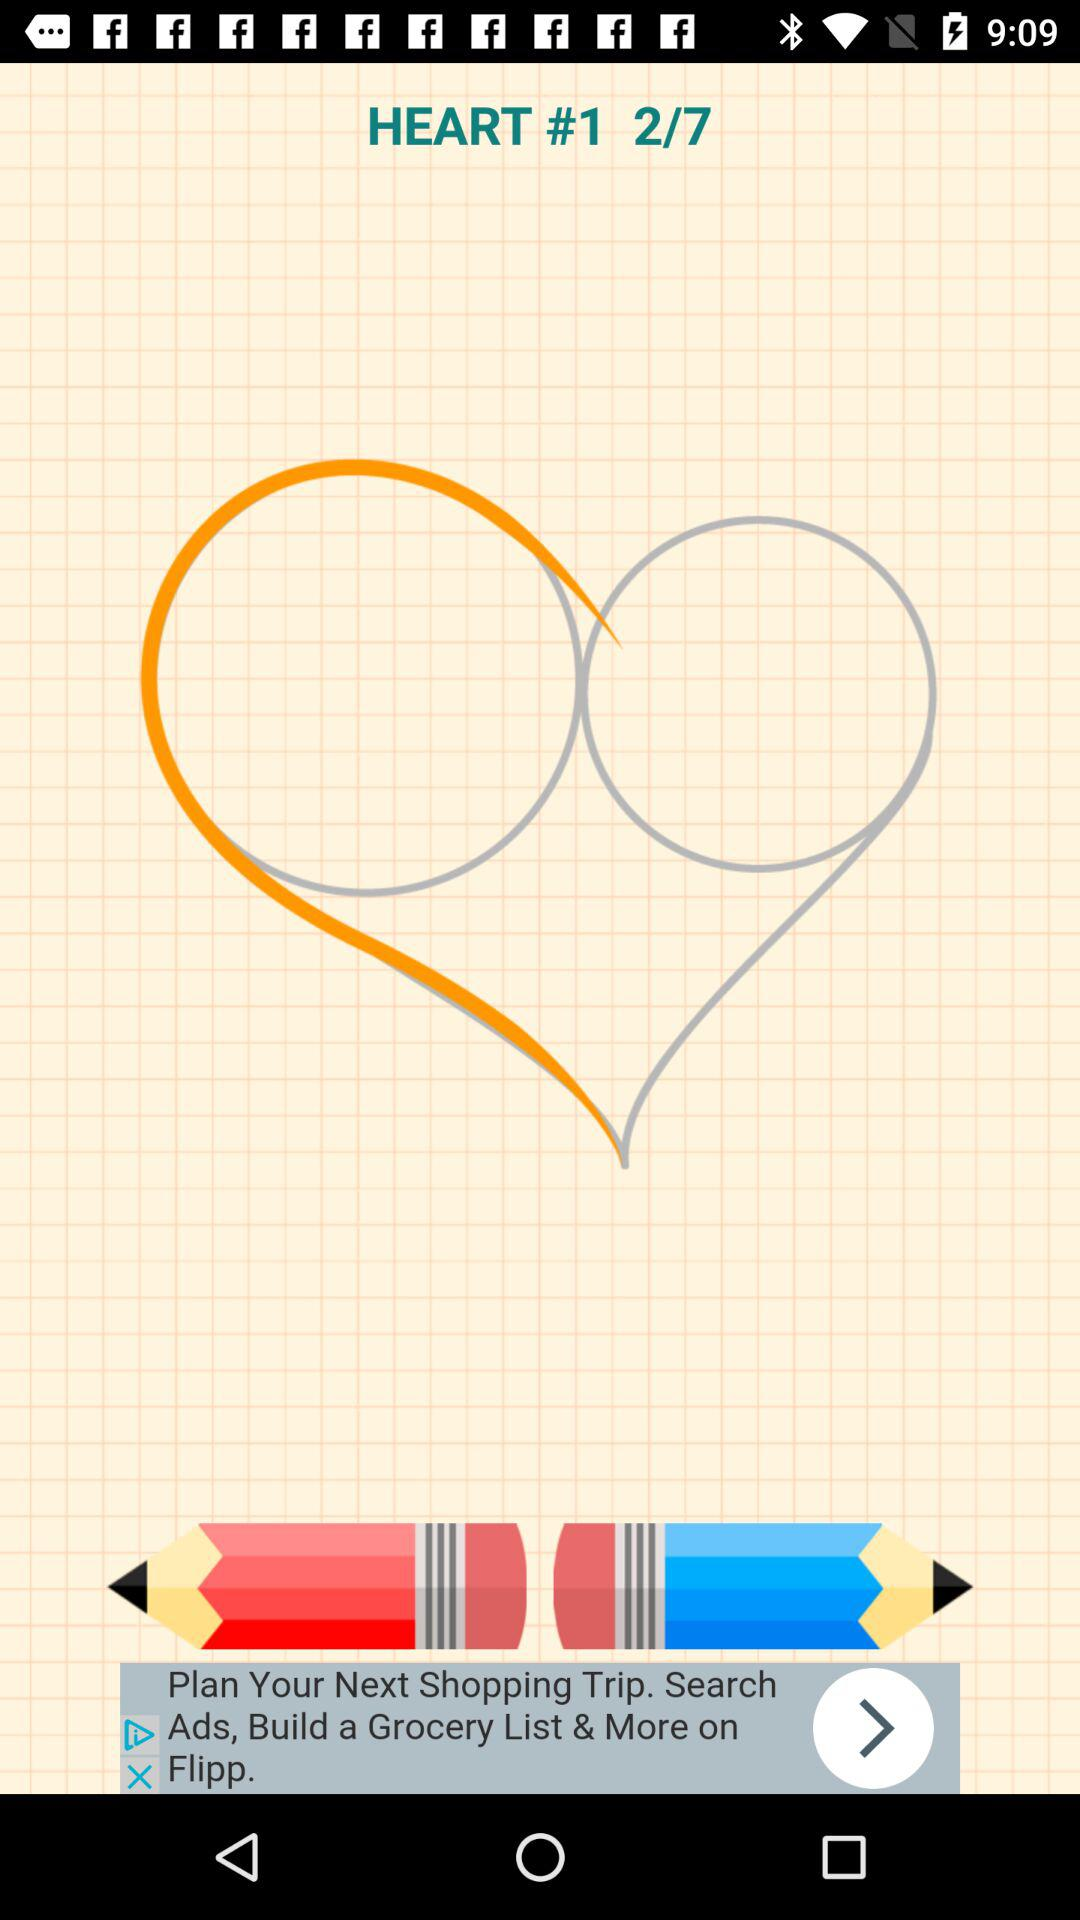At which image am I? You are at the second image. 